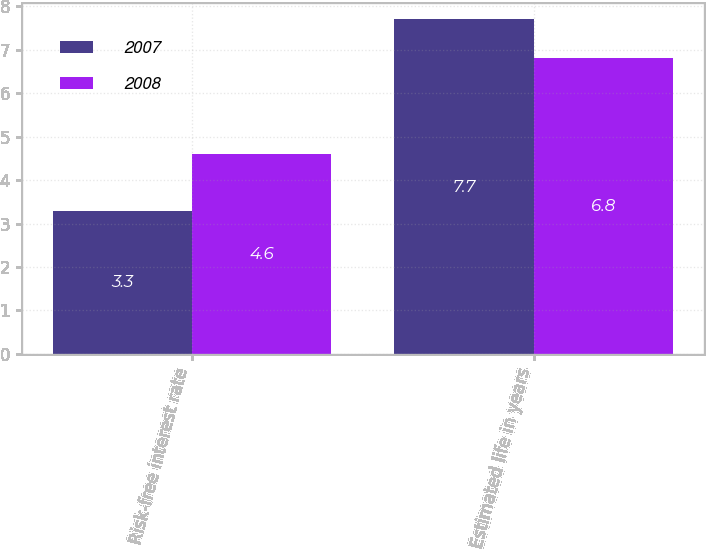Convert chart to OTSL. <chart><loc_0><loc_0><loc_500><loc_500><stacked_bar_chart><ecel><fcel>Risk-free interest rate<fcel>Estimated life in years<nl><fcel>2007<fcel>3.3<fcel>7.7<nl><fcel>2008<fcel>4.6<fcel>6.8<nl></chart> 